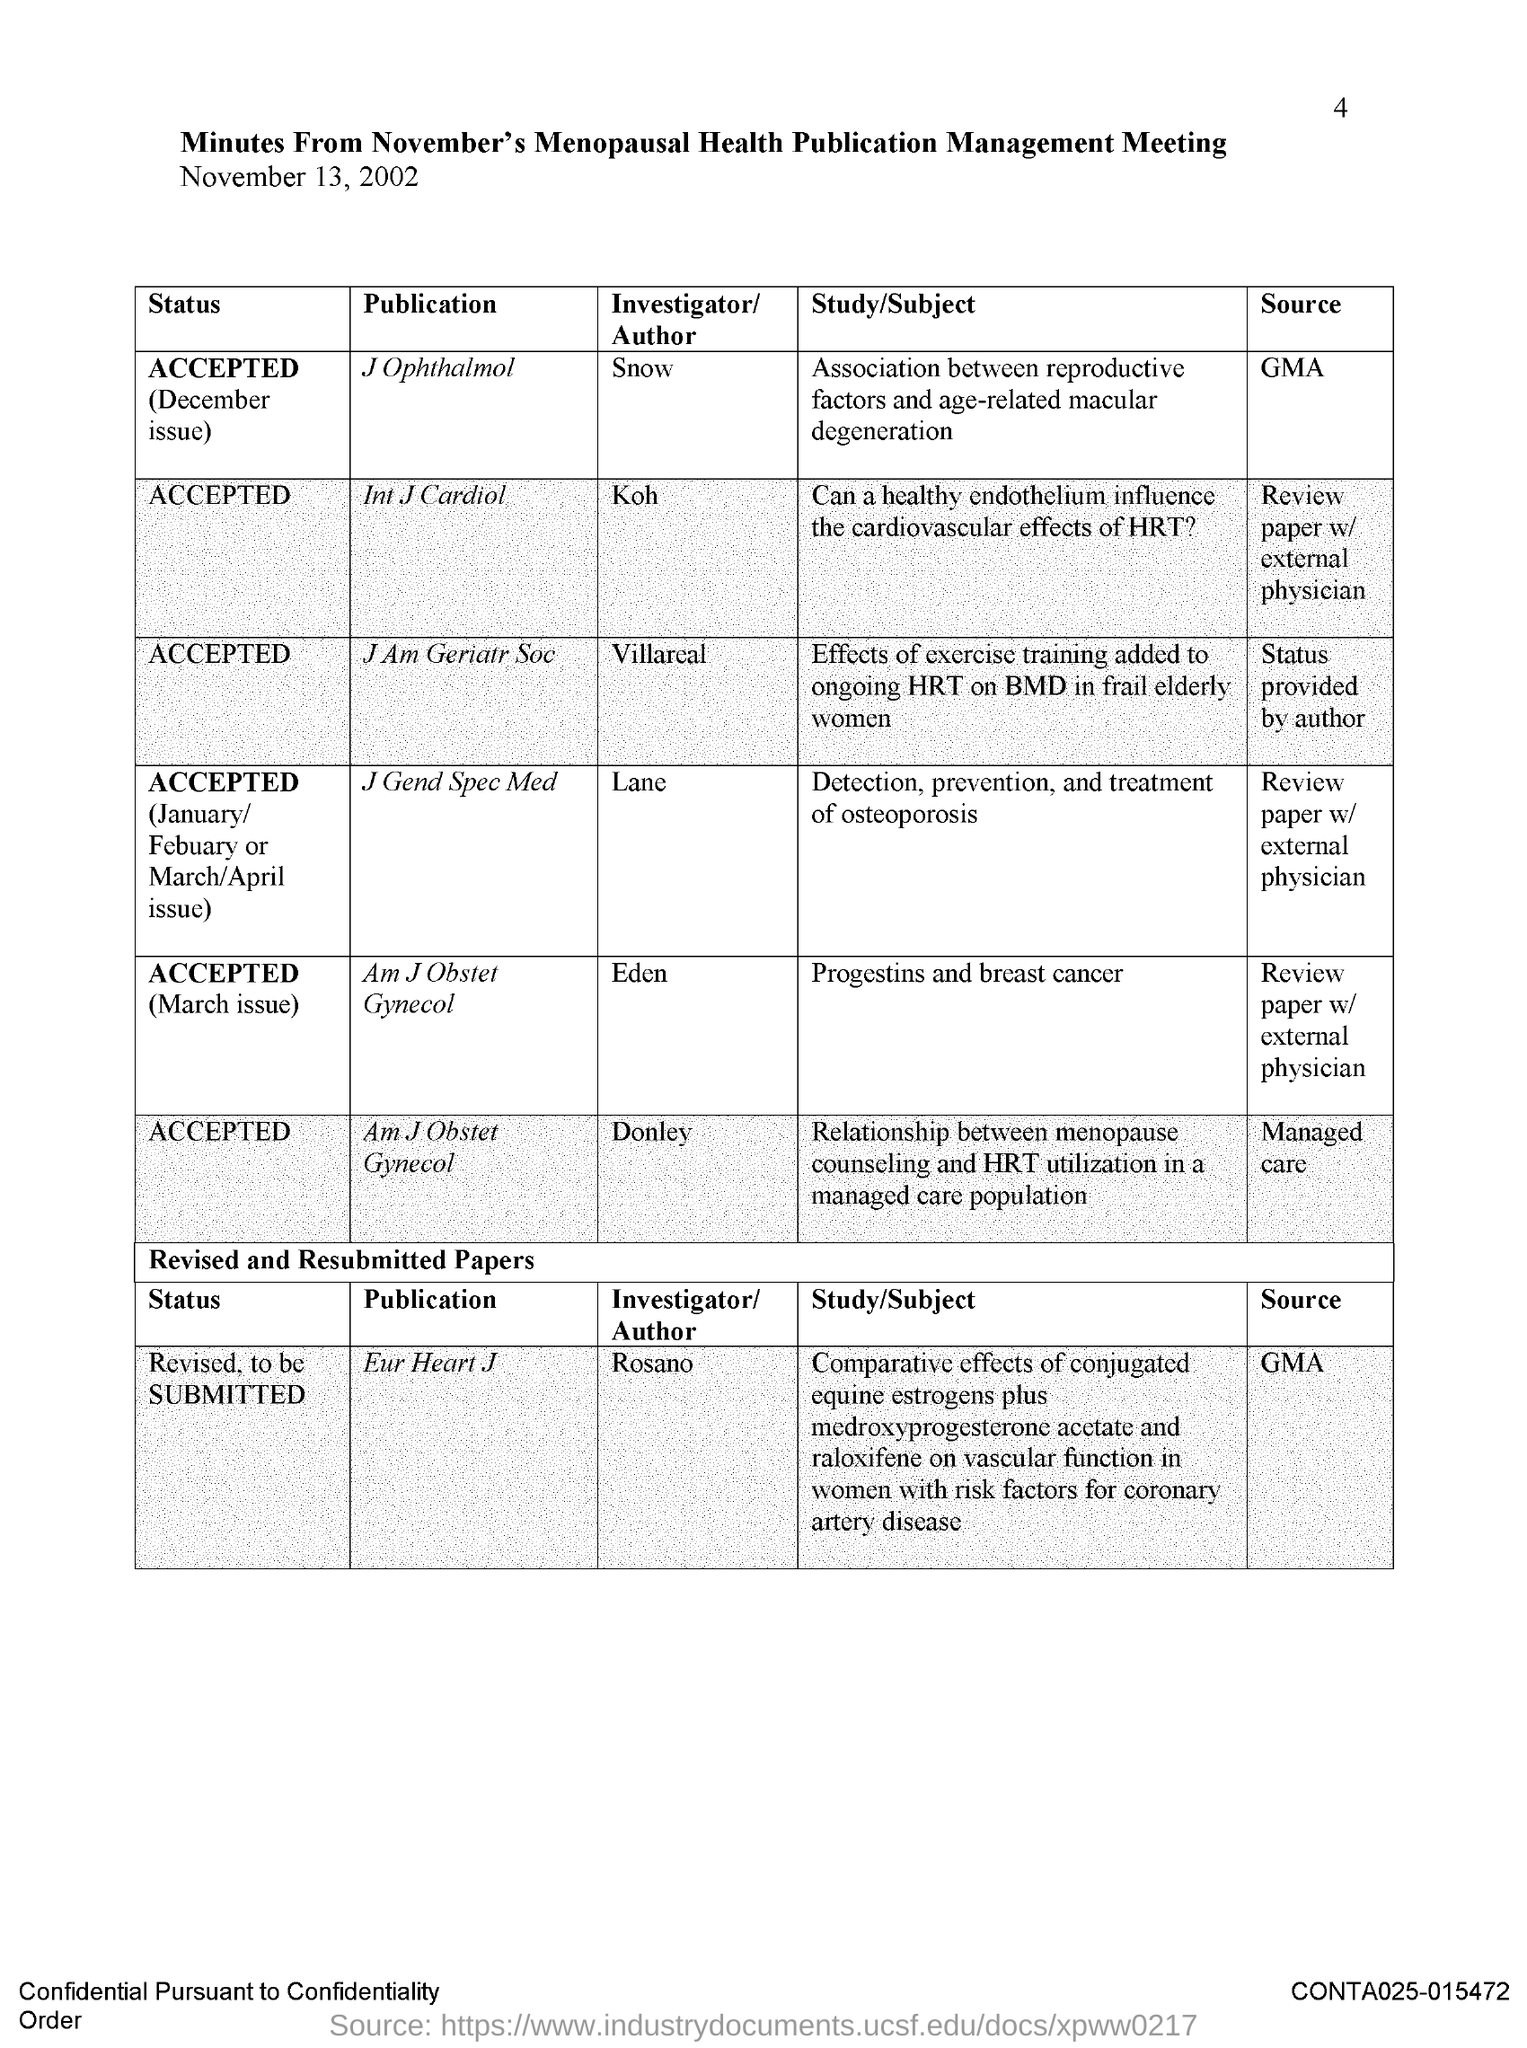Indicate a few pertinent items in this graphic. The publication "Int J Cardiol" has been accepted. The date mentioned in the document is November 13, 2002. It is known that the publication "Eur Heart J" was authored by Rosano. The page number is 4. It has been determined that the author of the publication "J Ophthalmol" is Snow, per the given information. 